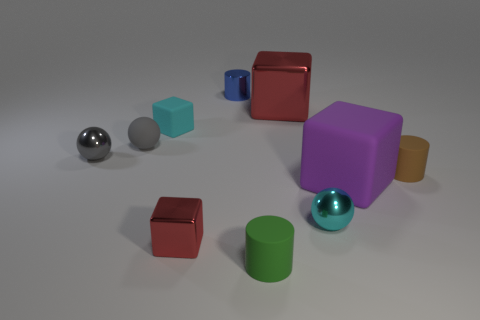Is there a metallic block that has the same color as the tiny matte block?
Offer a terse response. No. There is a matte cylinder to the left of the small cyan sphere; is it the same color as the tiny sphere on the right side of the small blue cylinder?
Ensure brevity in your answer.  No. There is another metal block that is the same color as the tiny shiny block; what size is it?
Offer a very short reply. Large. Are there any tiny blue cylinders that have the same material as the big red thing?
Your answer should be very brief. Yes. What is the color of the shiny cylinder?
Provide a succinct answer. Blue. There is a cylinder in front of the rubber block that is to the right of the tiny cylinder that is in front of the cyan metal ball; what is its size?
Make the answer very short. Small. What number of other things are there of the same shape as the cyan rubber thing?
Your answer should be very brief. 3. There is a tiny matte thing that is both on the right side of the tiny red shiny cube and behind the green cylinder; what color is it?
Give a very brief answer. Brown. Is there any other thing that is the same size as the matte ball?
Your answer should be compact. Yes. Is the color of the rubber cylinder that is behind the big purple object the same as the big rubber cube?
Your answer should be compact. No. 